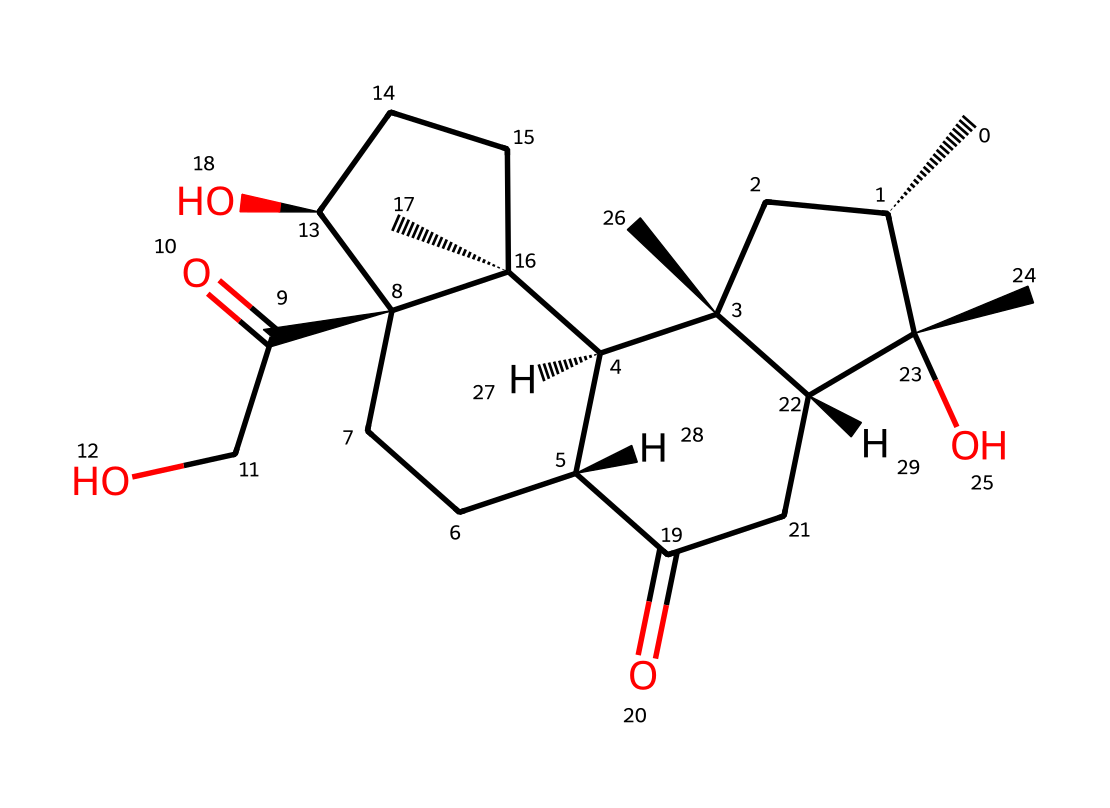What is the primary functional group in this chemical structure? The chemical structure contains a carbonyl group (C=O) and hydroxyl groups (-OH) indicating that it is a steroid with ketone and alcohol functionalities.
Answer: carbonyl group How many rings are present in this chemical? By analyzing the structure, I can identify four interconnected cycloalkane rings in the steroid skeleton.
Answer: four rings What type of compound is represented by this structure? The presence of the characteristic steroid structure along with its functional groups signifies that this compound is a steroid hormone often involved in inflammation response and regulation.
Answer: steroid hormone Does this chemical contain any hydroxyl groups? Inspecting the structure shows multiple instances of hydroxyl (-OH) groups attached to the steroid framework, confirming their presence.
Answer: yes What is the molecular formula of this chemical? By counting the number of each type of atom in the SMILES representation, I find that it consists of 21 carbon atoms (C), 30 hydrogen atoms (H), and 5 oxygen atoms (O).
Answer: C21H30O5 What is the role of this compound in treating sports inflammation? The chemical acts as a corticosteroid, which is used in medicine to help reduce inflammation and relieve symptoms associated with conditions affecting athletes, such as joint pain or swelling.
Answer: reduces inflammation 